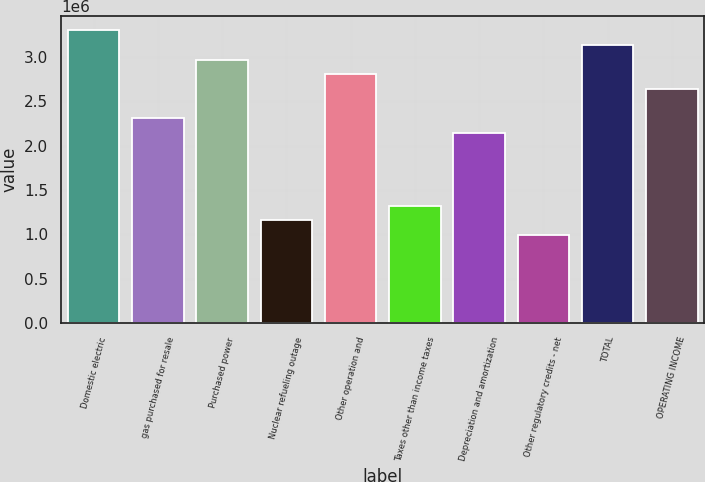Convert chart to OTSL. <chart><loc_0><loc_0><loc_500><loc_500><bar_chart><fcel>Domestic electric<fcel>gas purchased for resale<fcel>Purchased power<fcel>Nuclear refueling outage<fcel>Other operation and<fcel>Taxes other than income taxes<fcel>Depreciation and amortization<fcel>Other regulatory credits - net<fcel>TOTAL<fcel>OPERATING INCOME<nl><fcel>3.30138e+06<fcel>2.31244e+06<fcel>2.97173e+06<fcel>1.15867e+06<fcel>2.80691e+06<fcel>1.3235e+06<fcel>2.14762e+06<fcel>993851<fcel>3.13656e+06<fcel>2.64209e+06<nl></chart> 